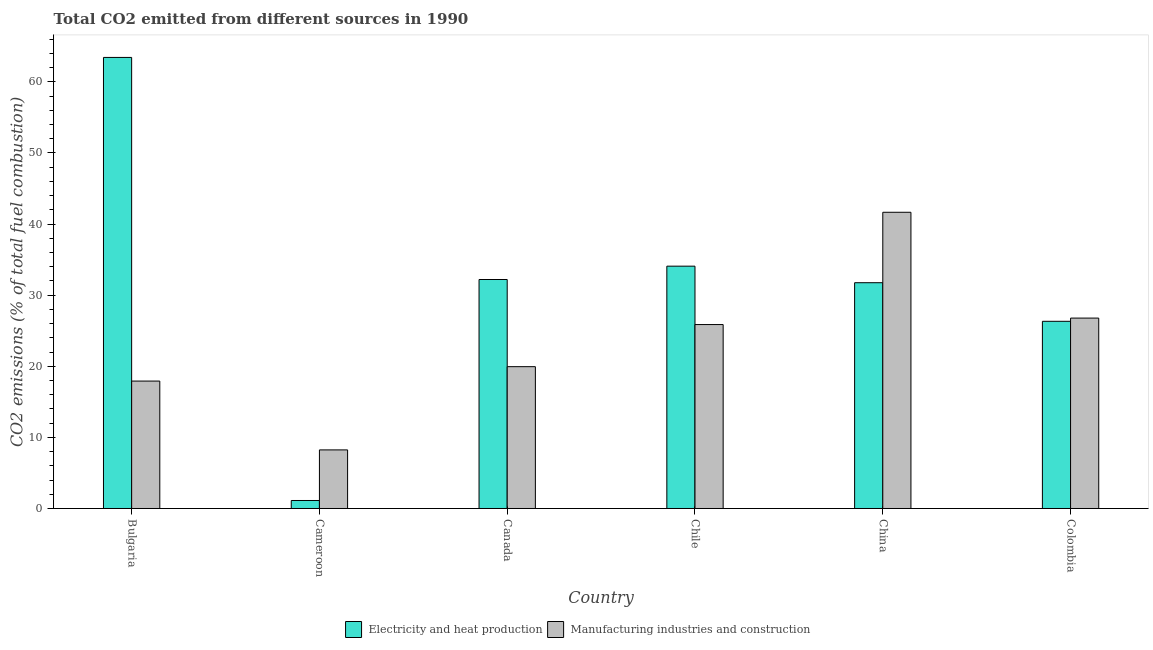How many groups of bars are there?
Keep it short and to the point. 6. How many bars are there on the 3rd tick from the right?
Provide a short and direct response. 2. What is the label of the 2nd group of bars from the left?
Provide a short and direct response. Cameroon. In how many cases, is the number of bars for a given country not equal to the number of legend labels?
Your response must be concise. 0. What is the co2 emissions due to electricity and heat production in Cameroon?
Make the answer very short. 1.12. Across all countries, what is the maximum co2 emissions due to electricity and heat production?
Offer a very short reply. 63.44. Across all countries, what is the minimum co2 emissions due to electricity and heat production?
Provide a short and direct response. 1.12. In which country was the co2 emissions due to manufacturing industries minimum?
Provide a succinct answer. Cameroon. What is the total co2 emissions due to manufacturing industries in the graph?
Provide a succinct answer. 140.41. What is the difference between the co2 emissions due to manufacturing industries in Bulgaria and that in Chile?
Give a very brief answer. -7.95. What is the difference between the co2 emissions due to manufacturing industries in China and the co2 emissions due to electricity and heat production in Colombia?
Give a very brief answer. 15.34. What is the average co2 emissions due to manufacturing industries per country?
Offer a terse response. 23.4. What is the difference between the co2 emissions due to manufacturing industries and co2 emissions due to electricity and heat production in Colombia?
Give a very brief answer. 0.45. In how many countries, is the co2 emissions due to electricity and heat production greater than 16 %?
Your answer should be very brief. 5. What is the ratio of the co2 emissions due to electricity and heat production in Cameroon to that in China?
Make the answer very short. 0.04. What is the difference between the highest and the second highest co2 emissions due to manufacturing industries?
Your answer should be compact. 14.88. What is the difference between the highest and the lowest co2 emissions due to electricity and heat production?
Make the answer very short. 62.31. Is the sum of the co2 emissions due to electricity and heat production in Cameroon and Colombia greater than the maximum co2 emissions due to manufacturing industries across all countries?
Provide a short and direct response. No. What does the 1st bar from the left in Colombia represents?
Make the answer very short. Electricity and heat production. What does the 1st bar from the right in Chile represents?
Offer a terse response. Manufacturing industries and construction. Are the values on the major ticks of Y-axis written in scientific E-notation?
Keep it short and to the point. No. Does the graph contain grids?
Provide a short and direct response. No. How many legend labels are there?
Provide a short and direct response. 2. What is the title of the graph?
Your answer should be very brief. Total CO2 emitted from different sources in 1990. What is the label or title of the X-axis?
Your answer should be very brief. Country. What is the label or title of the Y-axis?
Offer a terse response. CO2 emissions (% of total fuel combustion). What is the CO2 emissions (% of total fuel combustion) in Electricity and heat production in Bulgaria?
Keep it short and to the point. 63.44. What is the CO2 emissions (% of total fuel combustion) of Manufacturing industries and construction in Bulgaria?
Offer a very short reply. 17.92. What is the CO2 emissions (% of total fuel combustion) of Electricity and heat production in Cameroon?
Your answer should be compact. 1.12. What is the CO2 emissions (% of total fuel combustion) in Manufacturing industries and construction in Cameroon?
Make the answer very short. 8.24. What is the CO2 emissions (% of total fuel combustion) of Electricity and heat production in Canada?
Offer a terse response. 32.2. What is the CO2 emissions (% of total fuel combustion) of Manufacturing industries and construction in Canada?
Your answer should be compact. 19.95. What is the CO2 emissions (% of total fuel combustion) in Electricity and heat production in Chile?
Make the answer very short. 34.08. What is the CO2 emissions (% of total fuel combustion) of Manufacturing industries and construction in Chile?
Your response must be concise. 25.87. What is the CO2 emissions (% of total fuel combustion) of Electricity and heat production in China?
Your answer should be compact. 31.75. What is the CO2 emissions (% of total fuel combustion) of Manufacturing industries and construction in China?
Your answer should be compact. 41.66. What is the CO2 emissions (% of total fuel combustion) in Electricity and heat production in Colombia?
Make the answer very short. 26.32. What is the CO2 emissions (% of total fuel combustion) of Manufacturing industries and construction in Colombia?
Keep it short and to the point. 26.78. Across all countries, what is the maximum CO2 emissions (% of total fuel combustion) of Electricity and heat production?
Offer a very short reply. 63.44. Across all countries, what is the maximum CO2 emissions (% of total fuel combustion) of Manufacturing industries and construction?
Provide a succinct answer. 41.66. Across all countries, what is the minimum CO2 emissions (% of total fuel combustion) of Electricity and heat production?
Provide a succinct answer. 1.12. Across all countries, what is the minimum CO2 emissions (% of total fuel combustion) of Manufacturing industries and construction?
Keep it short and to the point. 8.24. What is the total CO2 emissions (% of total fuel combustion) of Electricity and heat production in the graph?
Your response must be concise. 188.92. What is the total CO2 emissions (% of total fuel combustion) in Manufacturing industries and construction in the graph?
Make the answer very short. 140.41. What is the difference between the CO2 emissions (% of total fuel combustion) of Electricity and heat production in Bulgaria and that in Cameroon?
Your response must be concise. 62.31. What is the difference between the CO2 emissions (% of total fuel combustion) in Manufacturing industries and construction in Bulgaria and that in Cameroon?
Your answer should be very brief. 9.68. What is the difference between the CO2 emissions (% of total fuel combustion) of Electricity and heat production in Bulgaria and that in Canada?
Offer a very short reply. 31.23. What is the difference between the CO2 emissions (% of total fuel combustion) of Manufacturing industries and construction in Bulgaria and that in Canada?
Offer a terse response. -2.03. What is the difference between the CO2 emissions (% of total fuel combustion) of Electricity and heat production in Bulgaria and that in Chile?
Provide a short and direct response. 29.36. What is the difference between the CO2 emissions (% of total fuel combustion) of Manufacturing industries and construction in Bulgaria and that in Chile?
Your answer should be compact. -7.95. What is the difference between the CO2 emissions (% of total fuel combustion) of Electricity and heat production in Bulgaria and that in China?
Offer a very short reply. 31.68. What is the difference between the CO2 emissions (% of total fuel combustion) of Manufacturing industries and construction in Bulgaria and that in China?
Provide a succinct answer. -23.74. What is the difference between the CO2 emissions (% of total fuel combustion) of Electricity and heat production in Bulgaria and that in Colombia?
Your answer should be compact. 37.11. What is the difference between the CO2 emissions (% of total fuel combustion) in Manufacturing industries and construction in Bulgaria and that in Colombia?
Provide a short and direct response. -8.86. What is the difference between the CO2 emissions (% of total fuel combustion) in Electricity and heat production in Cameroon and that in Canada?
Provide a succinct answer. -31.08. What is the difference between the CO2 emissions (% of total fuel combustion) of Manufacturing industries and construction in Cameroon and that in Canada?
Your answer should be compact. -11.71. What is the difference between the CO2 emissions (% of total fuel combustion) of Electricity and heat production in Cameroon and that in Chile?
Give a very brief answer. -32.96. What is the difference between the CO2 emissions (% of total fuel combustion) in Manufacturing industries and construction in Cameroon and that in Chile?
Provide a short and direct response. -17.63. What is the difference between the CO2 emissions (% of total fuel combustion) in Electricity and heat production in Cameroon and that in China?
Keep it short and to the point. -30.63. What is the difference between the CO2 emissions (% of total fuel combustion) of Manufacturing industries and construction in Cameroon and that in China?
Keep it short and to the point. -33.42. What is the difference between the CO2 emissions (% of total fuel combustion) in Electricity and heat production in Cameroon and that in Colombia?
Your response must be concise. -25.2. What is the difference between the CO2 emissions (% of total fuel combustion) of Manufacturing industries and construction in Cameroon and that in Colombia?
Provide a succinct answer. -18.54. What is the difference between the CO2 emissions (% of total fuel combustion) of Electricity and heat production in Canada and that in Chile?
Offer a terse response. -1.88. What is the difference between the CO2 emissions (% of total fuel combustion) of Manufacturing industries and construction in Canada and that in Chile?
Provide a short and direct response. -5.92. What is the difference between the CO2 emissions (% of total fuel combustion) of Electricity and heat production in Canada and that in China?
Your response must be concise. 0.45. What is the difference between the CO2 emissions (% of total fuel combustion) in Manufacturing industries and construction in Canada and that in China?
Offer a very short reply. -21.71. What is the difference between the CO2 emissions (% of total fuel combustion) of Electricity and heat production in Canada and that in Colombia?
Give a very brief answer. 5.88. What is the difference between the CO2 emissions (% of total fuel combustion) of Manufacturing industries and construction in Canada and that in Colombia?
Make the answer very short. -6.83. What is the difference between the CO2 emissions (% of total fuel combustion) in Electricity and heat production in Chile and that in China?
Provide a succinct answer. 2.33. What is the difference between the CO2 emissions (% of total fuel combustion) of Manufacturing industries and construction in Chile and that in China?
Your answer should be compact. -15.79. What is the difference between the CO2 emissions (% of total fuel combustion) in Electricity and heat production in Chile and that in Colombia?
Your answer should be compact. 7.75. What is the difference between the CO2 emissions (% of total fuel combustion) of Manufacturing industries and construction in Chile and that in Colombia?
Offer a very short reply. -0.91. What is the difference between the CO2 emissions (% of total fuel combustion) in Electricity and heat production in China and that in Colombia?
Give a very brief answer. 5.43. What is the difference between the CO2 emissions (% of total fuel combustion) of Manufacturing industries and construction in China and that in Colombia?
Your answer should be compact. 14.88. What is the difference between the CO2 emissions (% of total fuel combustion) in Electricity and heat production in Bulgaria and the CO2 emissions (% of total fuel combustion) in Manufacturing industries and construction in Cameroon?
Give a very brief answer. 55.2. What is the difference between the CO2 emissions (% of total fuel combustion) in Electricity and heat production in Bulgaria and the CO2 emissions (% of total fuel combustion) in Manufacturing industries and construction in Canada?
Provide a short and direct response. 43.49. What is the difference between the CO2 emissions (% of total fuel combustion) of Electricity and heat production in Bulgaria and the CO2 emissions (% of total fuel combustion) of Manufacturing industries and construction in Chile?
Your answer should be very brief. 37.57. What is the difference between the CO2 emissions (% of total fuel combustion) in Electricity and heat production in Bulgaria and the CO2 emissions (% of total fuel combustion) in Manufacturing industries and construction in China?
Give a very brief answer. 21.78. What is the difference between the CO2 emissions (% of total fuel combustion) of Electricity and heat production in Bulgaria and the CO2 emissions (% of total fuel combustion) of Manufacturing industries and construction in Colombia?
Your answer should be compact. 36.66. What is the difference between the CO2 emissions (% of total fuel combustion) of Electricity and heat production in Cameroon and the CO2 emissions (% of total fuel combustion) of Manufacturing industries and construction in Canada?
Your response must be concise. -18.82. What is the difference between the CO2 emissions (% of total fuel combustion) in Electricity and heat production in Cameroon and the CO2 emissions (% of total fuel combustion) in Manufacturing industries and construction in Chile?
Give a very brief answer. -24.74. What is the difference between the CO2 emissions (% of total fuel combustion) of Electricity and heat production in Cameroon and the CO2 emissions (% of total fuel combustion) of Manufacturing industries and construction in China?
Provide a succinct answer. -40.54. What is the difference between the CO2 emissions (% of total fuel combustion) of Electricity and heat production in Cameroon and the CO2 emissions (% of total fuel combustion) of Manufacturing industries and construction in Colombia?
Your answer should be very brief. -25.66. What is the difference between the CO2 emissions (% of total fuel combustion) in Electricity and heat production in Canada and the CO2 emissions (% of total fuel combustion) in Manufacturing industries and construction in Chile?
Provide a short and direct response. 6.34. What is the difference between the CO2 emissions (% of total fuel combustion) of Electricity and heat production in Canada and the CO2 emissions (% of total fuel combustion) of Manufacturing industries and construction in China?
Offer a terse response. -9.46. What is the difference between the CO2 emissions (% of total fuel combustion) in Electricity and heat production in Canada and the CO2 emissions (% of total fuel combustion) in Manufacturing industries and construction in Colombia?
Offer a very short reply. 5.43. What is the difference between the CO2 emissions (% of total fuel combustion) of Electricity and heat production in Chile and the CO2 emissions (% of total fuel combustion) of Manufacturing industries and construction in China?
Offer a very short reply. -7.58. What is the difference between the CO2 emissions (% of total fuel combustion) in Electricity and heat production in Chile and the CO2 emissions (% of total fuel combustion) in Manufacturing industries and construction in Colombia?
Your answer should be very brief. 7.3. What is the difference between the CO2 emissions (% of total fuel combustion) in Electricity and heat production in China and the CO2 emissions (% of total fuel combustion) in Manufacturing industries and construction in Colombia?
Provide a succinct answer. 4.97. What is the average CO2 emissions (% of total fuel combustion) in Electricity and heat production per country?
Offer a very short reply. 31.49. What is the average CO2 emissions (% of total fuel combustion) of Manufacturing industries and construction per country?
Make the answer very short. 23.4. What is the difference between the CO2 emissions (% of total fuel combustion) in Electricity and heat production and CO2 emissions (% of total fuel combustion) in Manufacturing industries and construction in Bulgaria?
Ensure brevity in your answer.  45.52. What is the difference between the CO2 emissions (% of total fuel combustion) of Electricity and heat production and CO2 emissions (% of total fuel combustion) of Manufacturing industries and construction in Cameroon?
Provide a succinct answer. -7.12. What is the difference between the CO2 emissions (% of total fuel combustion) in Electricity and heat production and CO2 emissions (% of total fuel combustion) in Manufacturing industries and construction in Canada?
Make the answer very short. 12.26. What is the difference between the CO2 emissions (% of total fuel combustion) in Electricity and heat production and CO2 emissions (% of total fuel combustion) in Manufacturing industries and construction in Chile?
Keep it short and to the point. 8.21. What is the difference between the CO2 emissions (% of total fuel combustion) in Electricity and heat production and CO2 emissions (% of total fuel combustion) in Manufacturing industries and construction in China?
Keep it short and to the point. -9.91. What is the difference between the CO2 emissions (% of total fuel combustion) of Electricity and heat production and CO2 emissions (% of total fuel combustion) of Manufacturing industries and construction in Colombia?
Make the answer very short. -0.45. What is the ratio of the CO2 emissions (% of total fuel combustion) in Electricity and heat production in Bulgaria to that in Cameroon?
Your response must be concise. 56.46. What is the ratio of the CO2 emissions (% of total fuel combustion) of Manufacturing industries and construction in Bulgaria to that in Cameroon?
Provide a short and direct response. 2.17. What is the ratio of the CO2 emissions (% of total fuel combustion) of Electricity and heat production in Bulgaria to that in Canada?
Your response must be concise. 1.97. What is the ratio of the CO2 emissions (% of total fuel combustion) of Manufacturing industries and construction in Bulgaria to that in Canada?
Your answer should be very brief. 0.9. What is the ratio of the CO2 emissions (% of total fuel combustion) in Electricity and heat production in Bulgaria to that in Chile?
Keep it short and to the point. 1.86. What is the ratio of the CO2 emissions (% of total fuel combustion) in Manufacturing industries and construction in Bulgaria to that in Chile?
Your response must be concise. 0.69. What is the ratio of the CO2 emissions (% of total fuel combustion) in Electricity and heat production in Bulgaria to that in China?
Ensure brevity in your answer.  2. What is the ratio of the CO2 emissions (% of total fuel combustion) in Manufacturing industries and construction in Bulgaria to that in China?
Provide a short and direct response. 0.43. What is the ratio of the CO2 emissions (% of total fuel combustion) in Electricity and heat production in Bulgaria to that in Colombia?
Make the answer very short. 2.41. What is the ratio of the CO2 emissions (% of total fuel combustion) of Manufacturing industries and construction in Bulgaria to that in Colombia?
Give a very brief answer. 0.67. What is the ratio of the CO2 emissions (% of total fuel combustion) in Electricity and heat production in Cameroon to that in Canada?
Keep it short and to the point. 0.03. What is the ratio of the CO2 emissions (% of total fuel combustion) in Manufacturing industries and construction in Cameroon to that in Canada?
Provide a short and direct response. 0.41. What is the ratio of the CO2 emissions (% of total fuel combustion) in Electricity and heat production in Cameroon to that in Chile?
Your answer should be very brief. 0.03. What is the ratio of the CO2 emissions (% of total fuel combustion) of Manufacturing industries and construction in Cameroon to that in Chile?
Keep it short and to the point. 0.32. What is the ratio of the CO2 emissions (% of total fuel combustion) in Electricity and heat production in Cameroon to that in China?
Provide a short and direct response. 0.04. What is the ratio of the CO2 emissions (% of total fuel combustion) in Manufacturing industries and construction in Cameroon to that in China?
Keep it short and to the point. 0.2. What is the ratio of the CO2 emissions (% of total fuel combustion) of Electricity and heat production in Cameroon to that in Colombia?
Your response must be concise. 0.04. What is the ratio of the CO2 emissions (% of total fuel combustion) of Manufacturing industries and construction in Cameroon to that in Colombia?
Your answer should be very brief. 0.31. What is the ratio of the CO2 emissions (% of total fuel combustion) in Electricity and heat production in Canada to that in Chile?
Provide a succinct answer. 0.94. What is the ratio of the CO2 emissions (% of total fuel combustion) in Manufacturing industries and construction in Canada to that in Chile?
Give a very brief answer. 0.77. What is the ratio of the CO2 emissions (% of total fuel combustion) in Electricity and heat production in Canada to that in China?
Keep it short and to the point. 1.01. What is the ratio of the CO2 emissions (% of total fuel combustion) in Manufacturing industries and construction in Canada to that in China?
Provide a succinct answer. 0.48. What is the ratio of the CO2 emissions (% of total fuel combustion) of Electricity and heat production in Canada to that in Colombia?
Provide a short and direct response. 1.22. What is the ratio of the CO2 emissions (% of total fuel combustion) in Manufacturing industries and construction in Canada to that in Colombia?
Your answer should be compact. 0.74. What is the ratio of the CO2 emissions (% of total fuel combustion) of Electricity and heat production in Chile to that in China?
Provide a succinct answer. 1.07. What is the ratio of the CO2 emissions (% of total fuel combustion) in Manufacturing industries and construction in Chile to that in China?
Your answer should be very brief. 0.62. What is the ratio of the CO2 emissions (% of total fuel combustion) in Electricity and heat production in Chile to that in Colombia?
Offer a terse response. 1.29. What is the ratio of the CO2 emissions (% of total fuel combustion) in Electricity and heat production in China to that in Colombia?
Give a very brief answer. 1.21. What is the ratio of the CO2 emissions (% of total fuel combustion) of Manufacturing industries and construction in China to that in Colombia?
Provide a short and direct response. 1.56. What is the difference between the highest and the second highest CO2 emissions (% of total fuel combustion) in Electricity and heat production?
Give a very brief answer. 29.36. What is the difference between the highest and the second highest CO2 emissions (% of total fuel combustion) of Manufacturing industries and construction?
Ensure brevity in your answer.  14.88. What is the difference between the highest and the lowest CO2 emissions (% of total fuel combustion) of Electricity and heat production?
Give a very brief answer. 62.31. What is the difference between the highest and the lowest CO2 emissions (% of total fuel combustion) in Manufacturing industries and construction?
Provide a short and direct response. 33.42. 